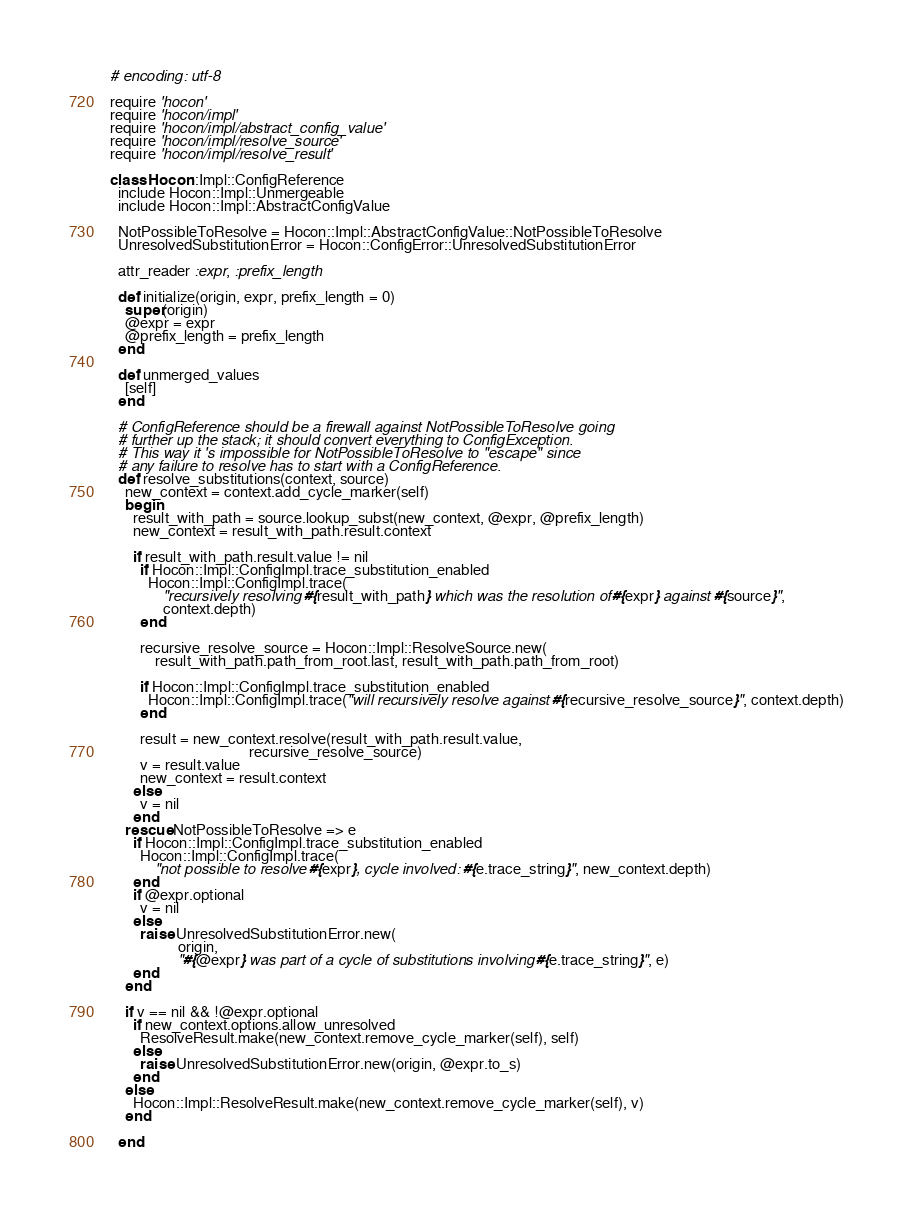Convert code to text. <code><loc_0><loc_0><loc_500><loc_500><_Ruby_># encoding: utf-8

require 'hocon'
require 'hocon/impl'
require 'hocon/impl/abstract_config_value'
require 'hocon/impl/resolve_source'
require 'hocon/impl/resolve_result'

class Hocon::Impl::ConfigReference
  include Hocon::Impl::Unmergeable
  include Hocon::Impl::AbstractConfigValue

  NotPossibleToResolve = Hocon::Impl::AbstractConfigValue::NotPossibleToResolve
  UnresolvedSubstitutionError = Hocon::ConfigError::UnresolvedSubstitutionError

  attr_reader :expr, :prefix_length

  def initialize(origin, expr, prefix_length = 0)
    super(origin)
    @expr = expr
    @prefix_length = prefix_length
  end

  def unmerged_values
    [self]
  end

  # ConfigReference should be a firewall against NotPossibleToResolve going
  # further up the stack; it should convert everything to ConfigException.
  # This way it 's impossible for NotPossibleToResolve to "escape" since
  # any failure to resolve has to start with a ConfigReference.
  def resolve_substitutions(context, source)
    new_context = context.add_cycle_marker(self)
    begin
      result_with_path = source.lookup_subst(new_context, @expr, @prefix_length)
      new_context = result_with_path.result.context

      if result_with_path.result.value != nil
        if Hocon::Impl::ConfigImpl.trace_substitution_enabled
          Hocon::Impl::ConfigImpl.trace(
              "recursively resolving #{result_with_path} which was the resolution of #{expr} against #{source}",
              context.depth)
        end

        recursive_resolve_source = Hocon::Impl::ResolveSource.new(
            result_with_path.path_from_root.last, result_with_path.path_from_root)

        if Hocon::Impl::ConfigImpl.trace_substitution_enabled
          Hocon::Impl::ConfigImpl.trace("will recursively resolve against #{recursive_resolve_source}", context.depth)
        end

        result = new_context.resolve(result_with_path.result.value,
                                     recursive_resolve_source)
        v = result.value
        new_context = result.context
      else
        v = nil
      end
    rescue NotPossibleToResolve => e
      if Hocon::Impl::ConfigImpl.trace_substitution_enabled
        Hocon::Impl::ConfigImpl.trace(
            "not possible to resolve #{expr}, cycle involved: #{e.trace_string}", new_context.depth)
      end
      if @expr.optional
        v = nil
      else
        raise UnresolvedSubstitutionError.new(
                  origin,
                  "#{@expr} was part of a cycle of substitutions involving #{e.trace_string}", e)
      end
    end

    if v == nil && !@expr.optional
      if new_context.options.allow_unresolved
        ResolveResult.make(new_context.remove_cycle_marker(self), self)
      else
        raise UnresolvedSubstitutionError.new(origin, @expr.to_s)
      end
    else
      Hocon::Impl::ResolveResult.make(new_context.remove_cycle_marker(self), v)
    end

  end
</code> 